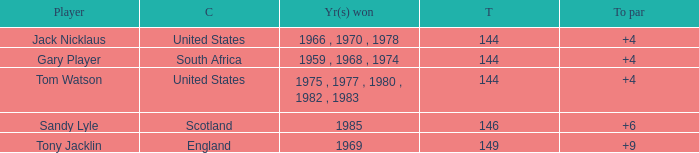What was Tom Watson's lowest To par when the total was larger than 144? None. 